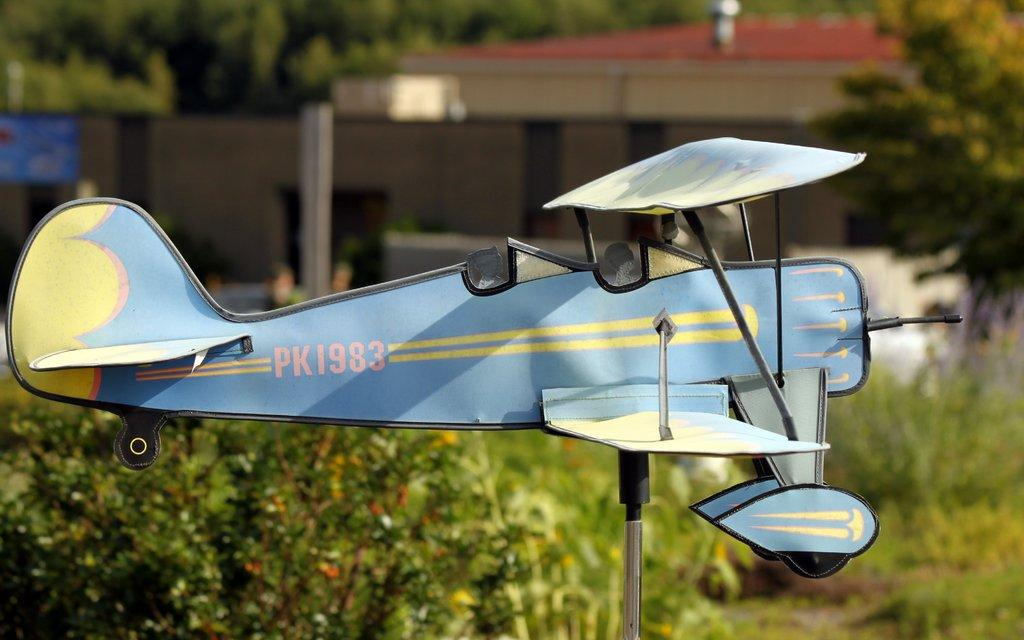Provide a one-sentence caption for the provided image. A small blue airplane with the tail sign PK1983. 